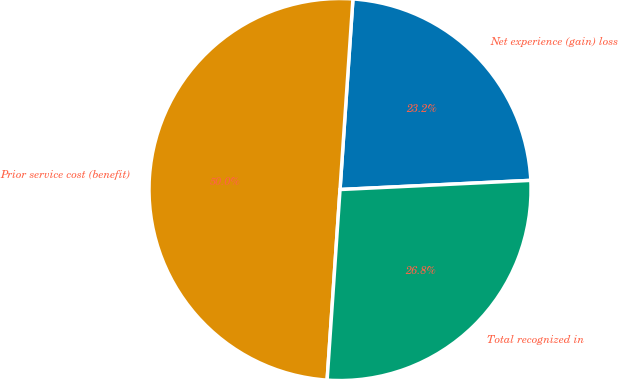Convert chart. <chart><loc_0><loc_0><loc_500><loc_500><pie_chart><fcel>Net experience (gain) loss<fcel>Prior service cost (benefit)<fcel>Total recognized in<nl><fcel>23.16%<fcel>50.0%<fcel>26.84%<nl></chart> 